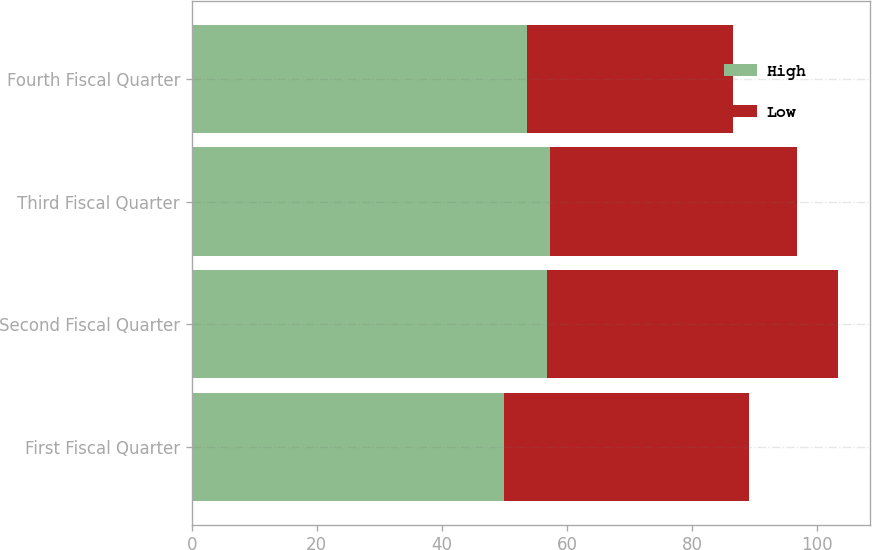<chart> <loc_0><loc_0><loc_500><loc_500><stacked_bar_chart><ecel><fcel>First Fiscal Quarter<fcel>Second Fiscal Quarter<fcel>Third Fiscal Quarter<fcel>Fourth Fiscal Quarter<nl><fcel>High<fcel>50<fcel>56.79<fcel>57.34<fcel>53.66<nl><fcel>Low<fcel>39.13<fcel>46.56<fcel>39.53<fcel>32.84<nl></chart> 